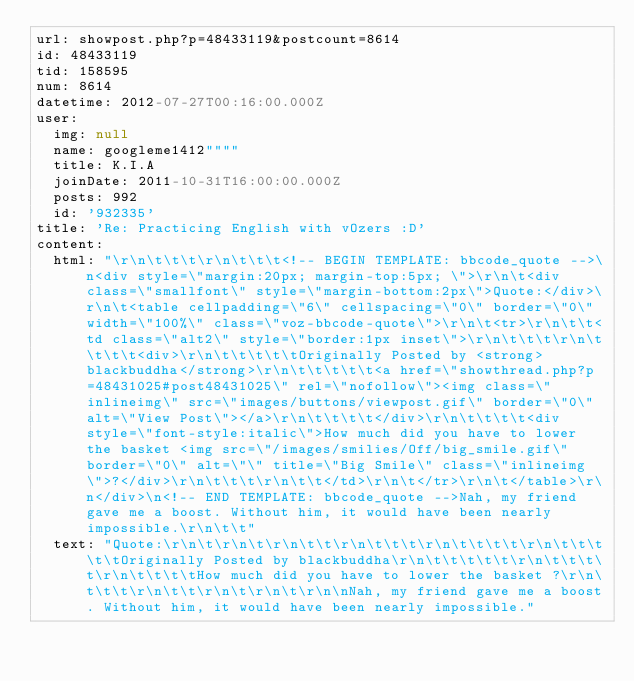<code> <loc_0><loc_0><loc_500><loc_500><_YAML_>url: showpost.php?p=48433119&postcount=8614
id: 48433119
tid: 158595
num: 8614
datetime: 2012-07-27T00:16:00.000Z
user:
  img: null
  name: googleme1412""""
  title: K.I.A
  joinDate: 2011-10-31T16:00:00.000Z
  posts: 992
  id: '932335'
title: 'Re: Practicing English with vOzers :D'
content:
  html: "\r\n\t\t\t\r\n\t\t\t<!-- BEGIN TEMPLATE: bbcode_quote -->\n<div style=\"margin:20px; margin-top:5px; \">\r\n\t<div class=\"smallfont\" style=\"margin-bottom:2px\">Quote:</div>\r\n\t<table cellpadding=\"6\" cellspacing=\"0\" border=\"0\" width=\"100%\" class=\"voz-bbcode-quote\">\r\n\t<tr>\r\n\t\t<td class=\"alt2\" style=\"border:1px inset\">\r\n\t\t\t\r\n\t\t\t\t<div>\r\n\t\t\t\t\tOriginally Posted by <strong>blackbuddha</strong>\r\n\t\t\t\t\t<a href=\"showthread.php?p=48431025#post48431025\" rel=\"nofollow\"><img class=\"inlineimg\" src=\"images/buttons/viewpost.gif\" border=\"0\" alt=\"View Post\"></a>\r\n\t\t\t\t</div>\r\n\t\t\t\t<div style=\"font-style:italic\">How much did you have to lower the basket <img src=\"/images/smilies/Off/big_smile.gif\" border=\"0\" alt=\"\" title=\"Big Smile\" class=\"inlineimg\">?</div>\r\n\t\t\t\r\n\t\t</td>\r\n\t</tr>\r\n\t</table>\r\n</div>\n<!-- END TEMPLATE: bbcode_quote -->Nah, my friend gave me a boost. Without him, it would have been nearly impossible.\r\n\t\t"
  text: "Quote:\r\n\t\r\n\t\r\n\t\t\r\n\t\t\t\r\n\t\t\t\t\r\n\t\t\t\t\tOriginally Posted by blackbuddha\r\n\t\t\t\t\t\r\n\t\t\t\t\r\n\t\t\t\tHow much did you have to lower the basket ?\r\n\t\t\t\r\n\t\t\r\n\t\r\n\t\r\n\nNah, my friend gave me a boost. Without him, it would have been nearly impossible."
</code> 